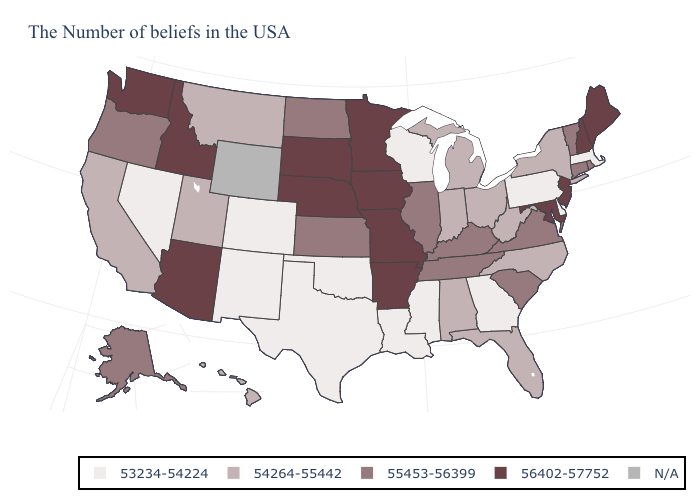Name the states that have a value in the range 54264-55442?
Quick response, please. New York, North Carolina, West Virginia, Ohio, Florida, Michigan, Indiana, Alabama, Utah, Montana, California, Hawaii. Does the first symbol in the legend represent the smallest category?
Give a very brief answer. Yes. Name the states that have a value in the range 53234-54224?
Concise answer only. Massachusetts, Delaware, Pennsylvania, Georgia, Wisconsin, Mississippi, Louisiana, Oklahoma, Texas, Colorado, New Mexico, Nevada. Does West Virginia have the highest value in the USA?
Be succinct. No. What is the value of Indiana?
Concise answer only. 54264-55442. Does Nevada have the lowest value in the West?
Quick response, please. Yes. Does Maine have the highest value in the Northeast?
Write a very short answer. Yes. What is the highest value in the USA?
Keep it brief. 56402-57752. Which states hav the highest value in the Northeast?
Concise answer only. Maine, New Hampshire, New Jersey. Name the states that have a value in the range 54264-55442?
Answer briefly. New York, North Carolina, West Virginia, Ohio, Florida, Michigan, Indiana, Alabama, Utah, Montana, California, Hawaii. Among the states that border South Dakota , does Montana have the lowest value?
Give a very brief answer. Yes. What is the value of Ohio?
Keep it brief. 54264-55442. Among the states that border Missouri , which have the highest value?
Concise answer only. Arkansas, Iowa, Nebraska. Does Wisconsin have the highest value in the USA?
Answer briefly. No. 